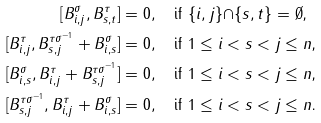Convert formula to latex. <formula><loc_0><loc_0><loc_500><loc_500>{ [ } B _ { i , j } ^ { \sigma } , B _ { s , t } ^ { \tau } ] & = 0 , \quad \text {if $\{i, j\}{\cap}\{s, t\} = \emptyset$,} \\ [ B _ { i , j } ^ { \tau } , B _ { s , j } ^ { { \tau } { \sigma } ^ { - 1 } } + B _ { i , s } ^ { \sigma } ] & = 0 , \quad \text {if $1 \leq i < s < j \leq n$,} \\ [ B _ { i , s } ^ { \sigma } , B _ { i , j } ^ { \tau } + B _ { s , j } ^ { { \tau } { \sigma } ^ { - 1 } } ] & = 0 , \quad \text {if $1 \leq i < s < j \leq n$,} \\ [ B _ { s , j } ^ { { \tau } { \sigma } ^ { - 1 } } , B _ { i , j } ^ { \tau } + B _ { i , s } ^ { \sigma } ] & = 0 , \quad \text {if $1 \leq i < s < j \leq n$.}</formula> 